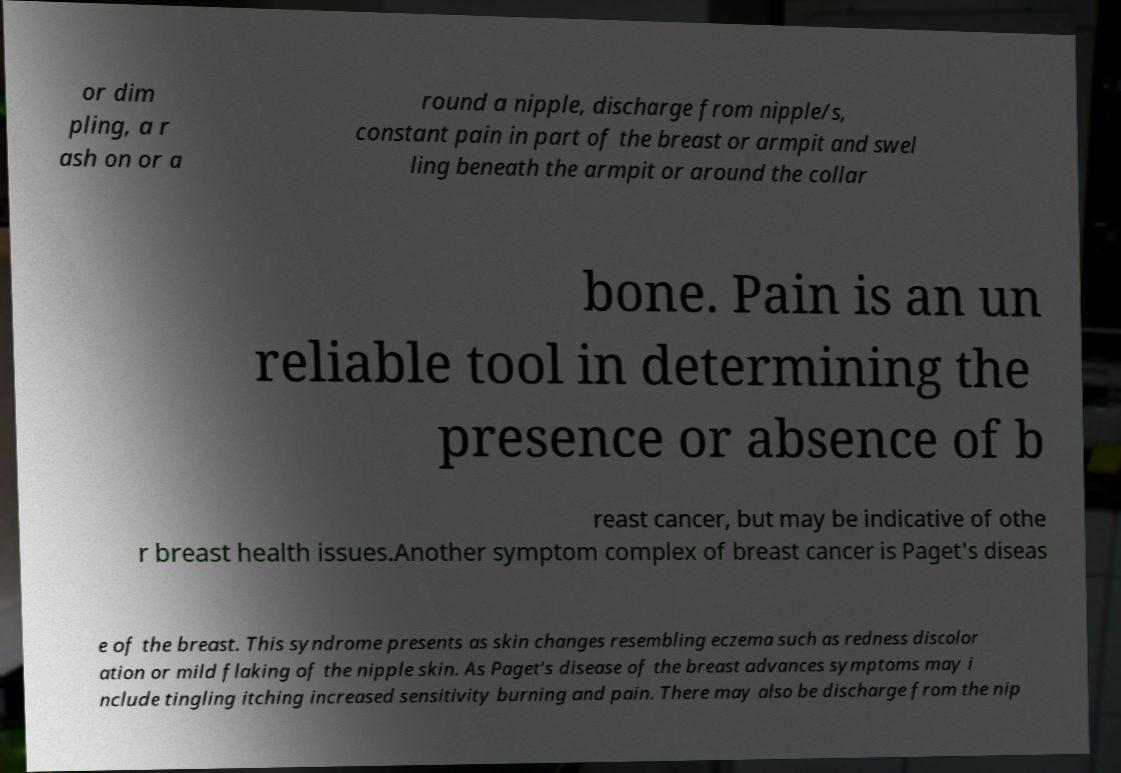What messages or text are displayed in this image? I need them in a readable, typed format. or dim pling, a r ash on or a round a nipple, discharge from nipple/s, constant pain in part of the breast or armpit and swel ling beneath the armpit or around the collar bone. Pain is an un reliable tool in determining the presence or absence of b reast cancer, but may be indicative of othe r breast health issues.Another symptom complex of breast cancer is Paget's diseas e of the breast. This syndrome presents as skin changes resembling eczema such as redness discolor ation or mild flaking of the nipple skin. As Paget's disease of the breast advances symptoms may i nclude tingling itching increased sensitivity burning and pain. There may also be discharge from the nip 